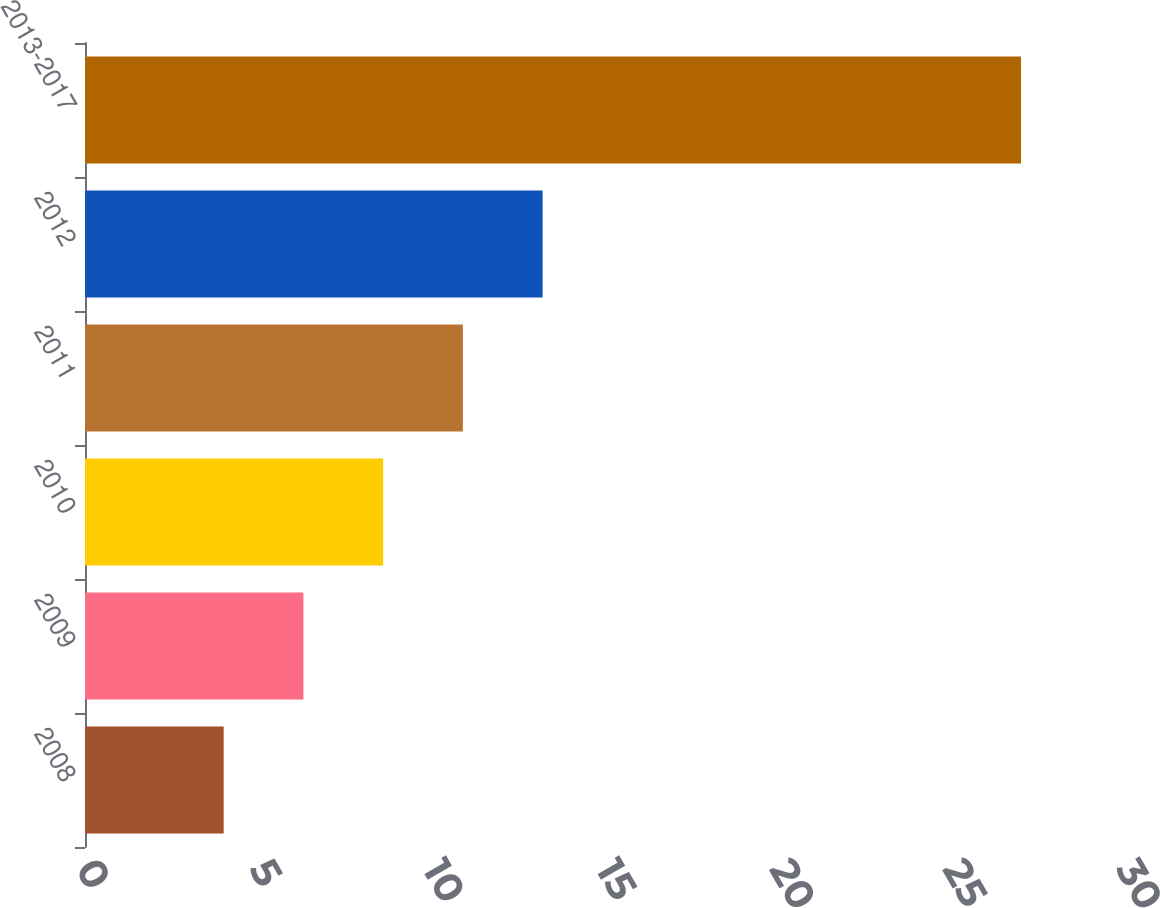<chart> <loc_0><loc_0><loc_500><loc_500><bar_chart><fcel>2008<fcel>2009<fcel>2010<fcel>2011<fcel>2012<fcel>2013-2017<nl><fcel>4<fcel>6.3<fcel>8.6<fcel>10.9<fcel>13.2<fcel>27<nl></chart> 